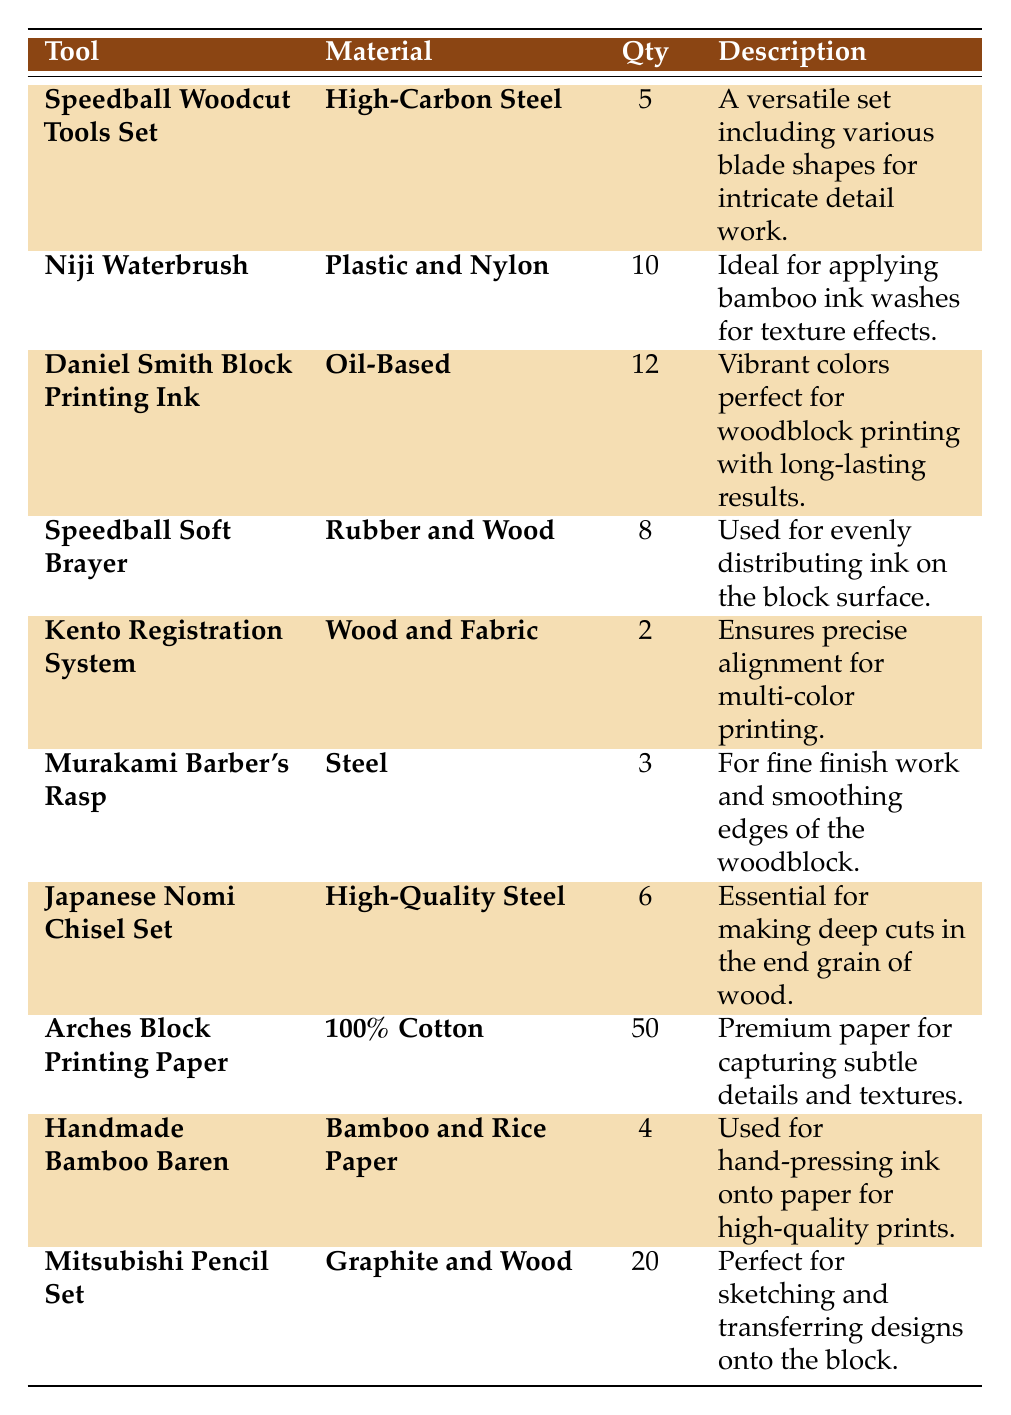What is the quantity of the **Speedball Woodcut Tools Set**? The table lists the **Speedball Woodcut Tools Set** under the tool column, and next to it, the quantity specified is 5.
Answer: 5 How many tools have a quantity greater than 5? The tools with quantities greater than 5 are **Niji Waterbrush** (10), **Daniel Smith Block Printing Ink** (12), and **Mitsubishi Pencil Set** (20), making a total of 3 tools.
Answer: 3 Is the **Kento Registration System** made of wood? The table states that the **Kento Registration System** is made of **Wood and Fabric**, confirming that it is indeed made of wood.
Answer: Yes What is the total quantity of **Daniel Smith Block Printing Ink** and **Speedball Soft Brayer**? The quantity of **Daniel Smith Block Printing Ink** is 12, and **Speedball Soft Brayer** is 8. Adding these gives 12 + 8 = 20.
Answer: 20 Which tool has the highest quantity? By reviewing the quantities, **Arches Block Printing Paper** has the highest quantity at 50.
Answer: **Arches Block Printing Paper** How many tools have a material made from **steel**? The tools with steel in their material description are **Speedball Woodcut Tools Set**, **Murakami Barber's Rasp**, and **Japanese Nomi Chisel Set**. Thus, a total of 3 tools have steel as a material.
Answer: 3 What materials are used for the **Handmade Bamboo Baren**? The table indicates that the **Handmade Bamboo Baren** is made from **Bamboo and Rice Paper**.
Answer: Bamboo and Rice Paper What is the sum of quantities for tools made from **wood**? The tools made from wood are **Speedball Soft Brayer** (8), **Kento Registration System** (2). Adding these gives 8 + 2 = 10.
Answer: 10 Is there any tool with a quantity of less than 4? Checking the quantities, both the **Kento Registration System** (2) and **Handmade Bamboo Baren** (4) are under 4, confirming that yes, some tools have a quantity of less than 4.
Answer: Yes What is the average quantity of all tools listed? To find the average, first sum the quantities: 5 + 10 + 12 + 8 + 2 + 3 + 6 + 50 + 4 + 20 = 120. There are 10 tools, so the average is 120/10 = 12.
Answer: 12 